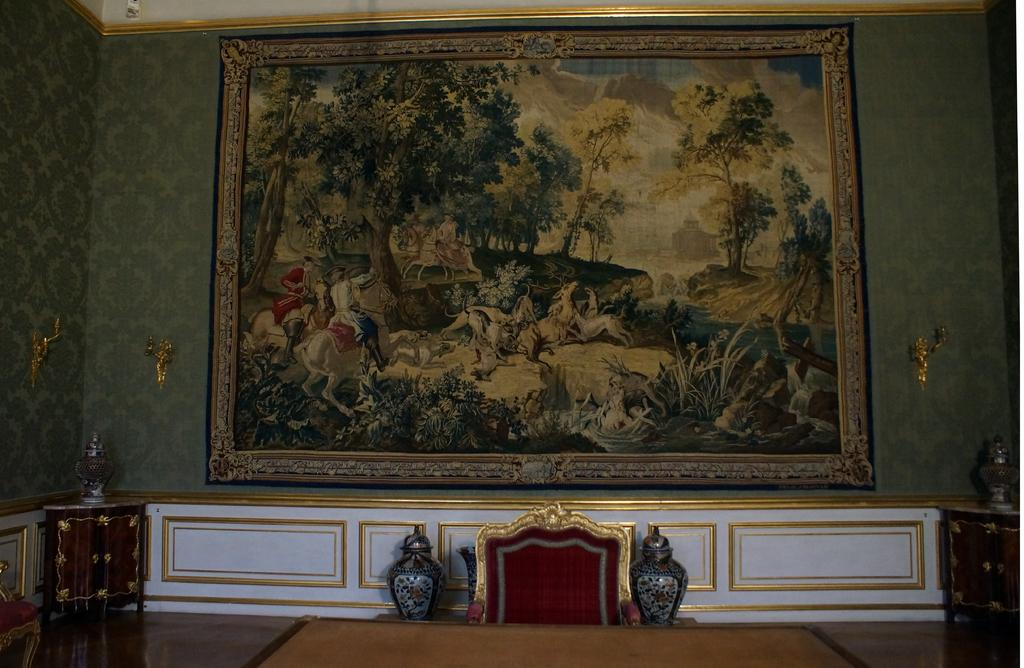What is hanging on the wall in the image? There is a painting on the wall. What is positioned in front of the painting? There is a chair and a table in front of the painting. What can be found on either side of the chair? There are jars on either side of the chair. How is the room arranged in terms of furniture? There are tables on either side of the room. What type of clouds can be seen in the painting? There is no mention of clouds in the provided facts, and the image does not show any clouds. Is there a cannon visible in the painting? There is no mention of a cannon in the provided facts, and the image does not show any cannons. 